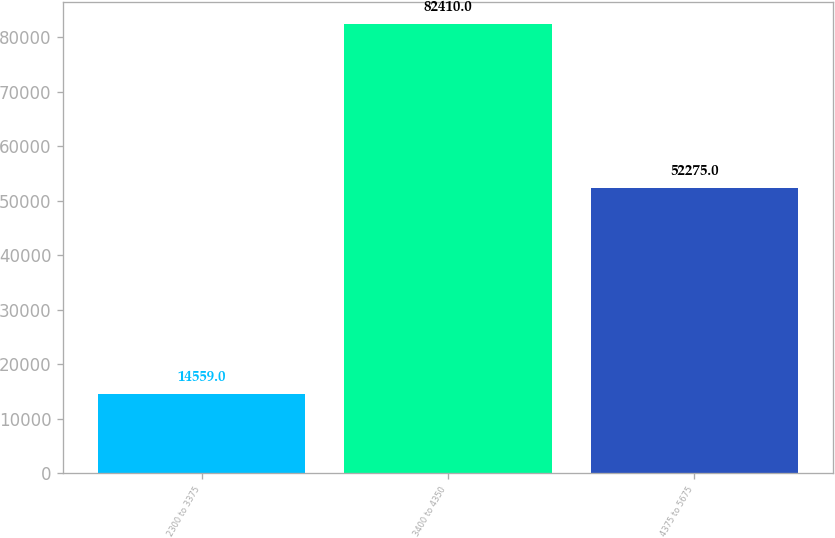Convert chart. <chart><loc_0><loc_0><loc_500><loc_500><bar_chart><fcel>2300 to 3375<fcel>3400 to 4350<fcel>4375 to 5675<nl><fcel>14559<fcel>82410<fcel>52275<nl></chart> 